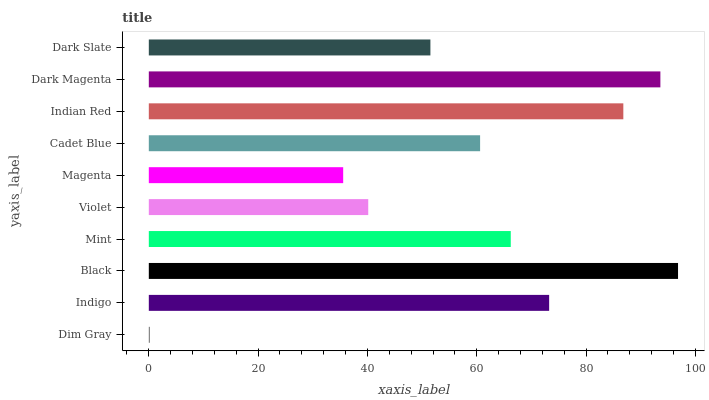Is Dim Gray the minimum?
Answer yes or no. Yes. Is Black the maximum?
Answer yes or no. Yes. Is Indigo the minimum?
Answer yes or no. No. Is Indigo the maximum?
Answer yes or no. No. Is Indigo greater than Dim Gray?
Answer yes or no. Yes. Is Dim Gray less than Indigo?
Answer yes or no. Yes. Is Dim Gray greater than Indigo?
Answer yes or no. No. Is Indigo less than Dim Gray?
Answer yes or no. No. Is Mint the high median?
Answer yes or no. Yes. Is Cadet Blue the low median?
Answer yes or no. Yes. Is Indian Red the high median?
Answer yes or no. No. Is Dark Slate the low median?
Answer yes or no. No. 